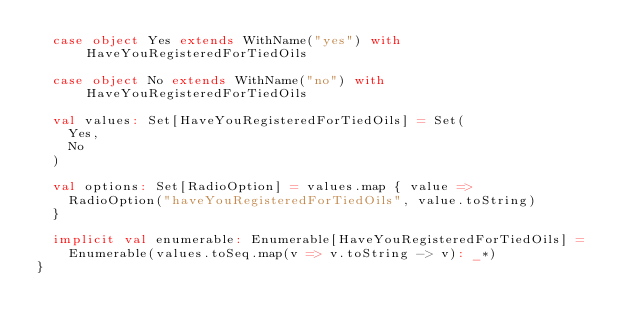Convert code to text. <code><loc_0><loc_0><loc_500><loc_500><_Scala_>  case object Yes extends WithName("yes") with HaveYouRegisteredForTiedOils

  case object No extends WithName("no") with HaveYouRegisteredForTiedOils

  val values: Set[HaveYouRegisteredForTiedOils] = Set(
    Yes,
    No
  )

  val options: Set[RadioOption] = values.map { value =>
    RadioOption("haveYouRegisteredForTiedOils", value.toString)
  }

  implicit val enumerable: Enumerable[HaveYouRegisteredForTiedOils] =
    Enumerable(values.toSeq.map(v => v.toString -> v): _*)
}
</code> 